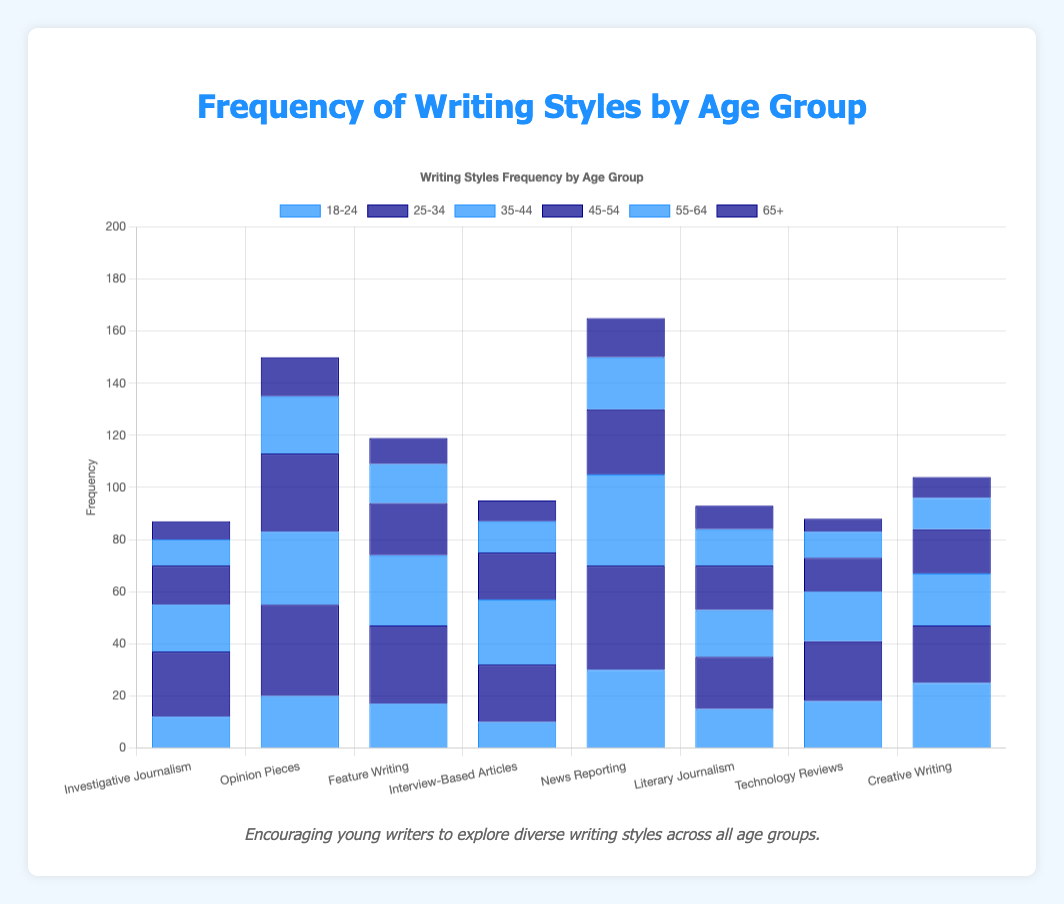Which writing style has the highest frequency among the 18-24 age group? The bar representing the 18-24 age group for "News Reporting" is the tallest, indicating the highest frequency.
Answer: News Reporting Which age group contributes most to "Creative Writing"? Look at the tallest bar in the "Creative Writing" category. The 18-24 age group's bar is the tallest.
Answer: 18-24 What is the sum of frequencies for "Feature Writing" across all age groups? Add the frequencies for "Feature Writing" across all age groups: 17 (18-24) + 30 (25-34) + 27 (35-44) + 20 (45-54) + 15 (55-64) + 10 (65+) = 119.
Answer: 119 Is the frequency of "Opinion Pieces" higher for the 35-44 age group or the 45-54 age group? Compare the bar heights for "Opinion Pieces" in the 35-44 and 45-54 age groups. The 45-54 bar is taller than the 35-44 bar.
Answer: 45-54 How does the frequency of "Technology Reviews" for the 65+ age group compare to the 18-24 age group? Compare the bar heights for "Technology Reviews." The 65+ bar is shorter than the 18-24 bar.
Answer: Less Which writing style shows the least frequency for the 65+ age group? Look at the shortest bar among all writing styles for the 65+ age group. "Technology Reviews" has the shortest bar.
Answer: Technology Reviews What is the difference in frequency for "Investigative Journalism" between the 25-34 and 35-44 age groups? Subtract the frequency for the 35-44 group from the 25-34 group for "Investigative Journalism": 25 - 18 = 7.
Answer: 7 For "News Reporting," what is the frequency ratio between the 25-34 and 55-64 age groups? Divide the frequency of the 25-34 group by the 55-64 group for "News Reporting": 40 / 20 = 2.
Answer: 2 Among "Literary Journalism," "Interview-Based Articles," and "Investigation Journalism," which age group has the highest combined frequency? Sum the frequencies for each age group across the three styles and compare: For the 25-34 group: 20 + 22 + 25 = 67. This is the highest combined frequency.
Answer: 25-34 